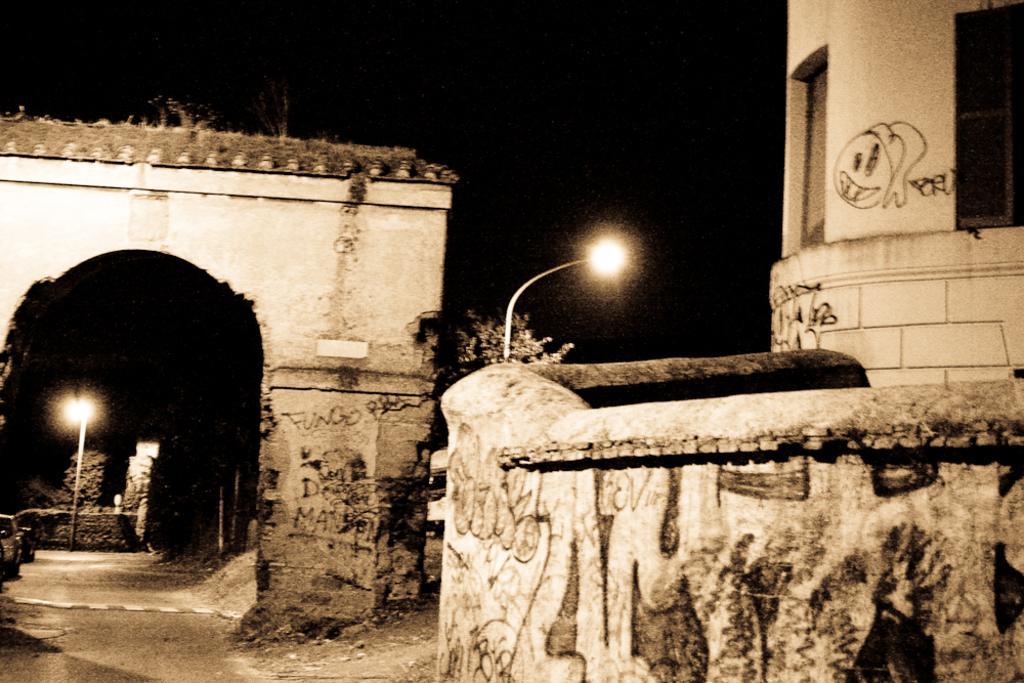Please provide a concise description of this image. In the picture we can see a wall and on it we can see a part of the pole with a light and beside it, we can see a part of the house wall and on the other side, we can see a gateway and from it we can see a pole with light and behind it we can see a tree. 